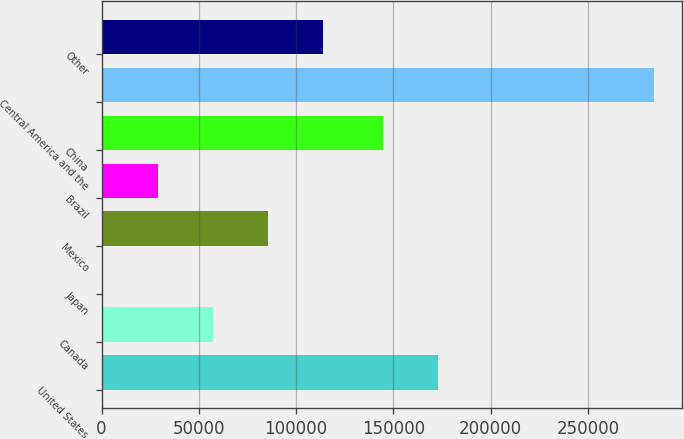Convert chart to OTSL. <chart><loc_0><loc_0><loc_500><loc_500><bar_chart><fcel>United States<fcel>Canada<fcel>Japan<fcel>Mexico<fcel>Brazil<fcel>China<fcel>Central America and the<fcel>Other<nl><fcel>172996<fcel>57146.4<fcel>456<fcel>85491.6<fcel>28801.2<fcel>144651<fcel>283908<fcel>113837<nl></chart> 